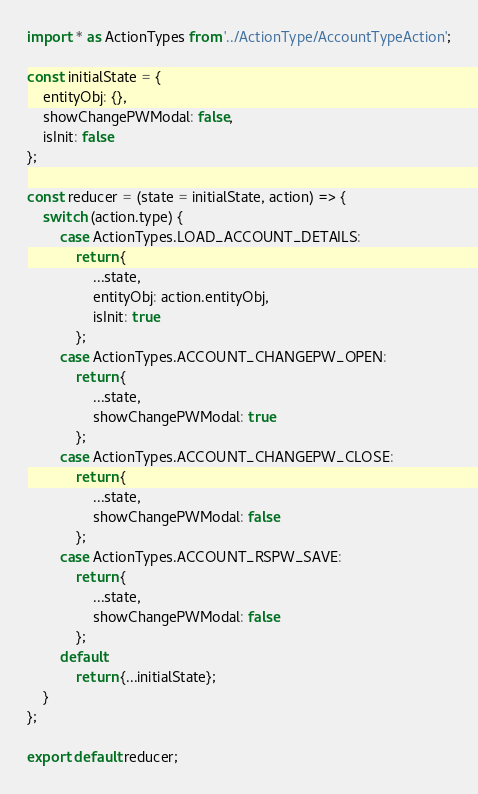<code> <loc_0><loc_0><loc_500><loc_500><_JavaScript_>import * as ActionTypes from '../ActionType/AccountTypeAction';

const initialState = {
    entityObj: {},
    showChangePWModal: false,
    isInit: false
};

const reducer = (state = initialState, action) => {
    switch (action.type) {
        case ActionTypes.LOAD_ACCOUNT_DETAILS:
            return {
                ...state,
                entityObj: action.entityObj,
                isInit: true
            };
        case ActionTypes.ACCOUNT_CHANGEPW_OPEN:
            return {
                ...state,
                showChangePWModal: true
            };
        case ActionTypes.ACCOUNT_CHANGEPW_CLOSE:
            return {
                ...state,
                showChangePWModal: false
            };
        case ActionTypes.ACCOUNT_RSPW_SAVE:
            return {
                ...state,
                showChangePWModal: false
            };
        default:
            return {...initialState};
    }
};

export default reducer;
</code> 